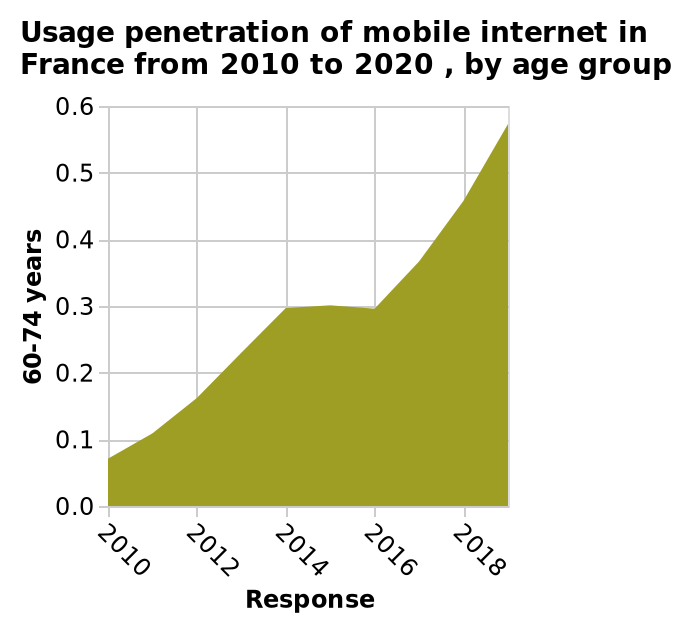<image>
Does the usage increase or decrease with age in recent years? The usage increases with age in recent years. What is measured on the x-axis of the graph? The response is measured on the x-axis of the graph. 